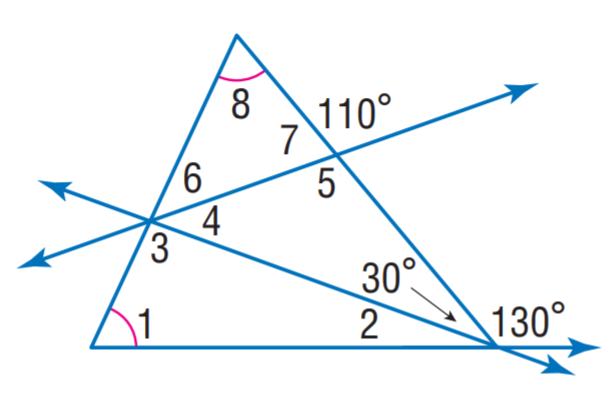Answer the mathemtical geometry problem and directly provide the correct option letter.
Question: Find m \angle 1.
Choices: A: 20 B: 40 C: 65 D: 95 C 